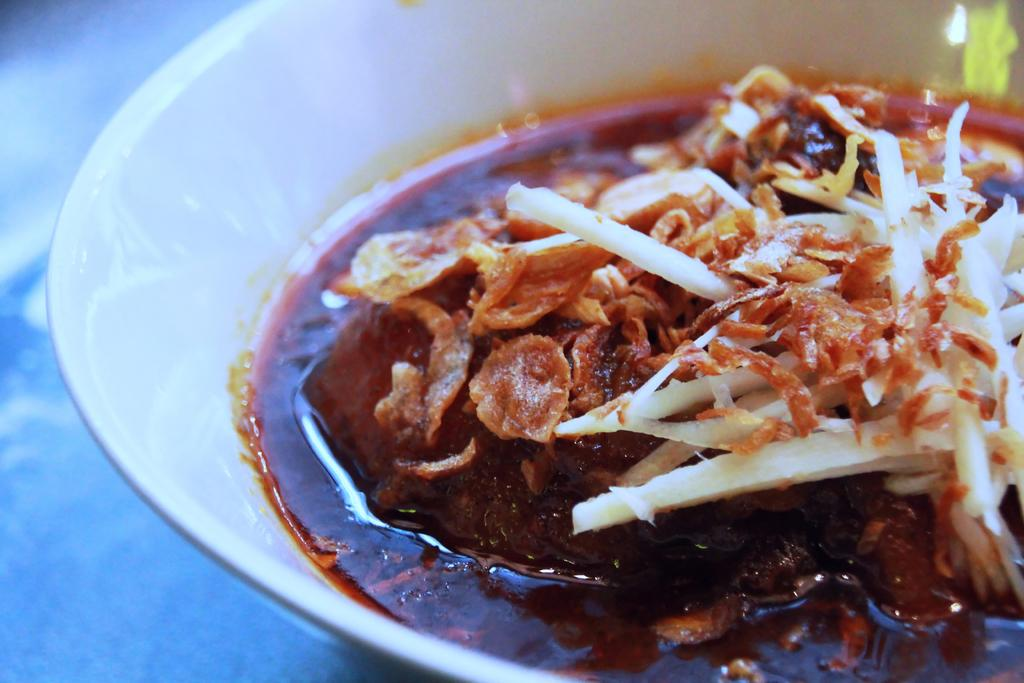What is in the bowl that is visible in the image? There is a bowl with food in the image. Where is the bowl located in the image? The bowl is placed on a table. What type of rings can be seen on the person's fingers in the image? There are no people or rings present in the image; it only features a bowl with food placed on a table. 